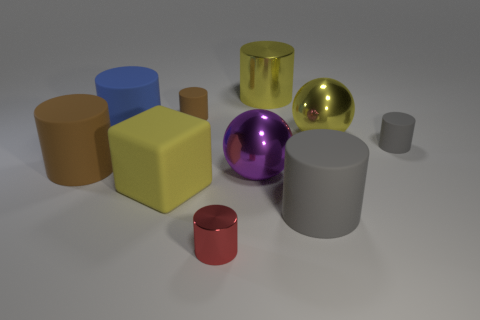Subtract all green balls. How many brown cylinders are left? 2 Subtract all small shiny cylinders. How many cylinders are left? 6 Subtract all yellow cylinders. How many cylinders are left? 6 Subtract 1 cylinders. How many cylinders are left? 6 Subtract all blue cylinders. Subtract all red balls. How many cylinders are left? 6 Subtract all cubes. How many objects are left? 9 Add 3 blue shiny balls. How many blue shiny balls exist? 3 Subtract 0 cyan cylinders. How many objects are left? 10 Subtract all metal cylinders. Subtract all gray cylinders. How many objects are left? 6 Add 7 purple shiny objects. How many purple shiny objects are left? 8 